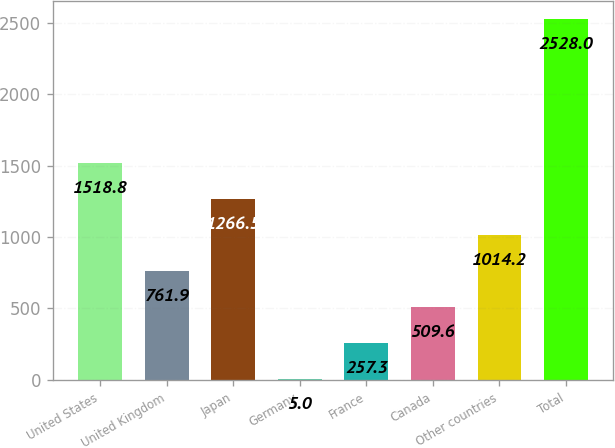Convert chart to OTSL. <chart><loc_0><loc_0><loc_500><loc_500><bar_chart><fcel>United States<fcel>United Kingdom<fcel>Japan<fcel>Germany<fcel>France<fcel>Canada<fcel>Other countries<fcel>Total<nl><fcel>1518.8<fcel>761.9<fcel>1266.5<fcel>5<fcel>257.3<fcel>509.6<fcel>1014.2<fcel>2528<nl></chart> 